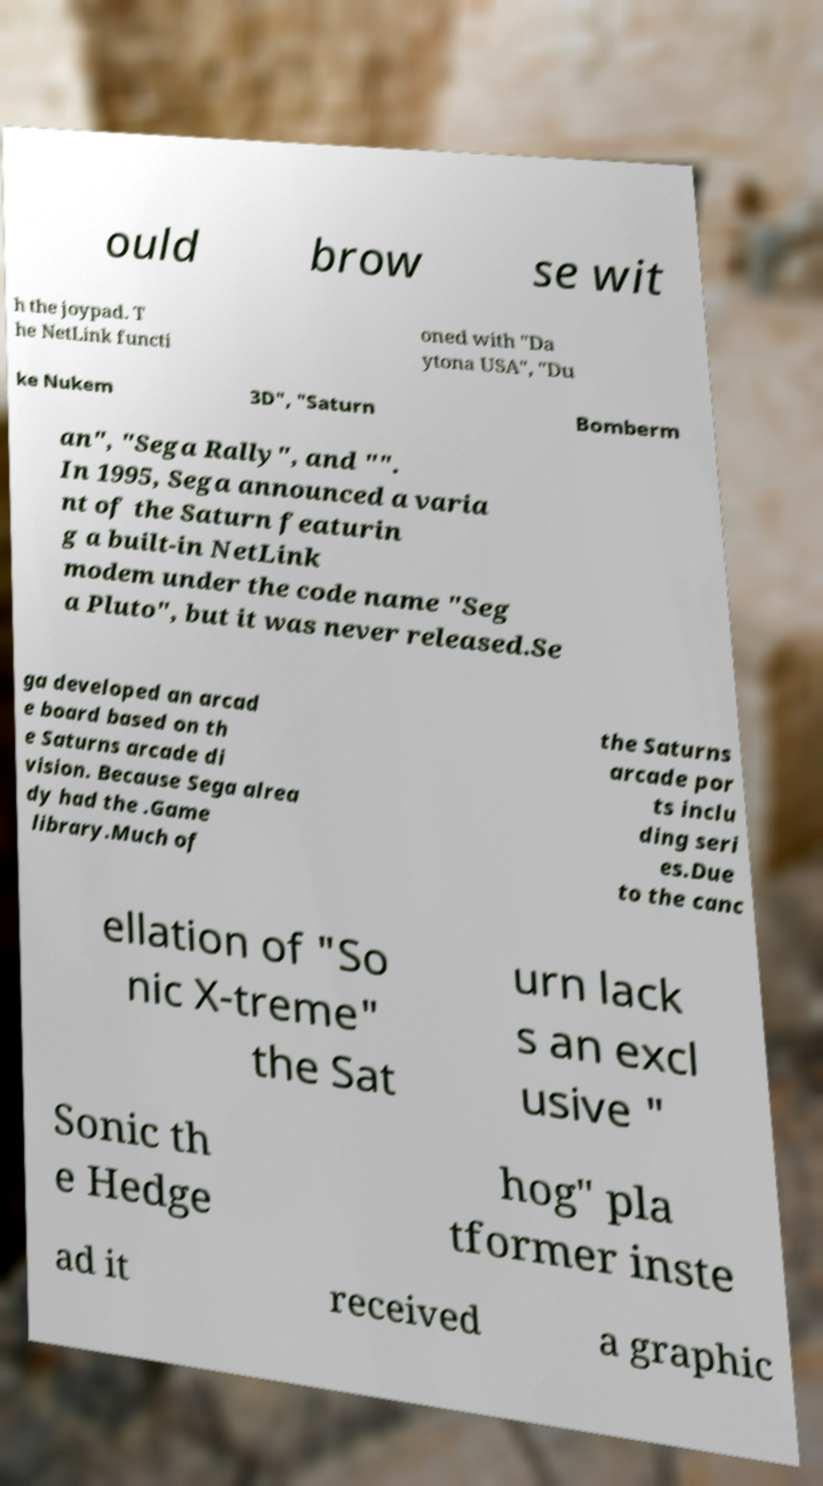What messages or text are displayed in this image? I need them in a readable, typed format. ould brow se wit h the joypad. T he NetLink functi oned with "Da ytona USA", "Du ke Nukem 3D", "Saturn Bomberm an", "Sega Rally", and "". In 1995, Sega announced a varia nt of the Saturn featurin g a built-in NetLink modem under the code name "Seg a Pluto", but it was never released.Se ga developed an arcad e board based on th e Saturns arcade di vision. Because Sega alrea dy had the .Game library.Much of the Saturns arcade por ts inclu ding seri es.Due to the canc ellation of "So nic X-treme" the Sat urn lack s an excl usive " Sonic th e Hedge hog" pla tformer inste ad it received a graphic 